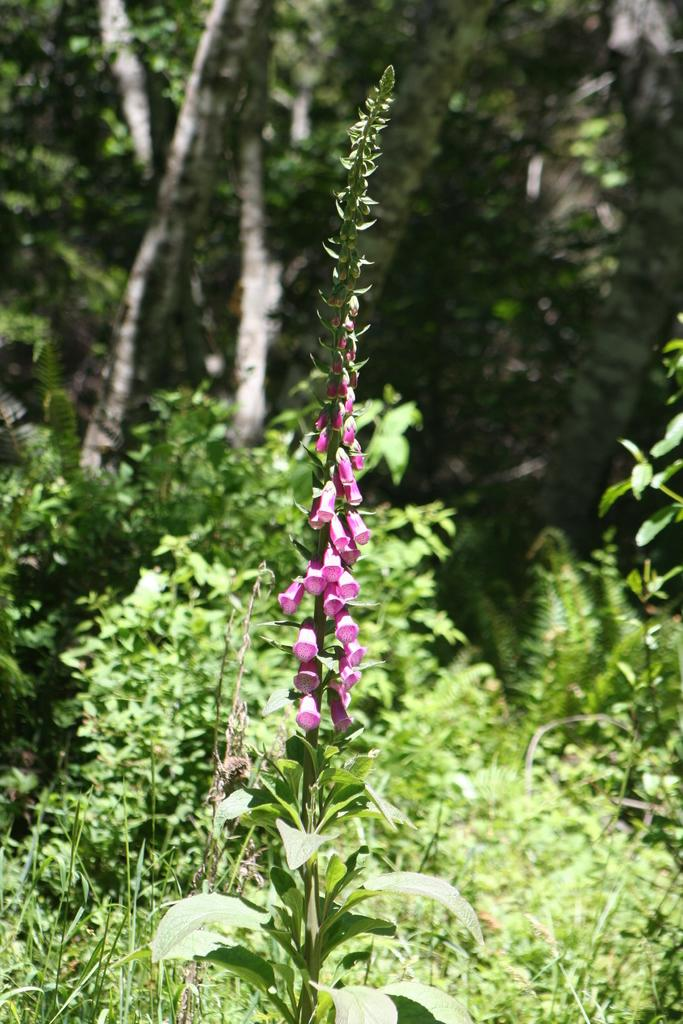What type of living organisms can be seen in the image? Plants and trees are visible in the image. What color are the flowers on the plants in the image? There are pink flowers in the image. What type of insect can be seen crawling through the hole in the image? There is no insect or hole present in the image. What type of pleasure can be derived from the image? The image is not associated with any specific pleasure or emotion; it simply depicts plants and flowers. 